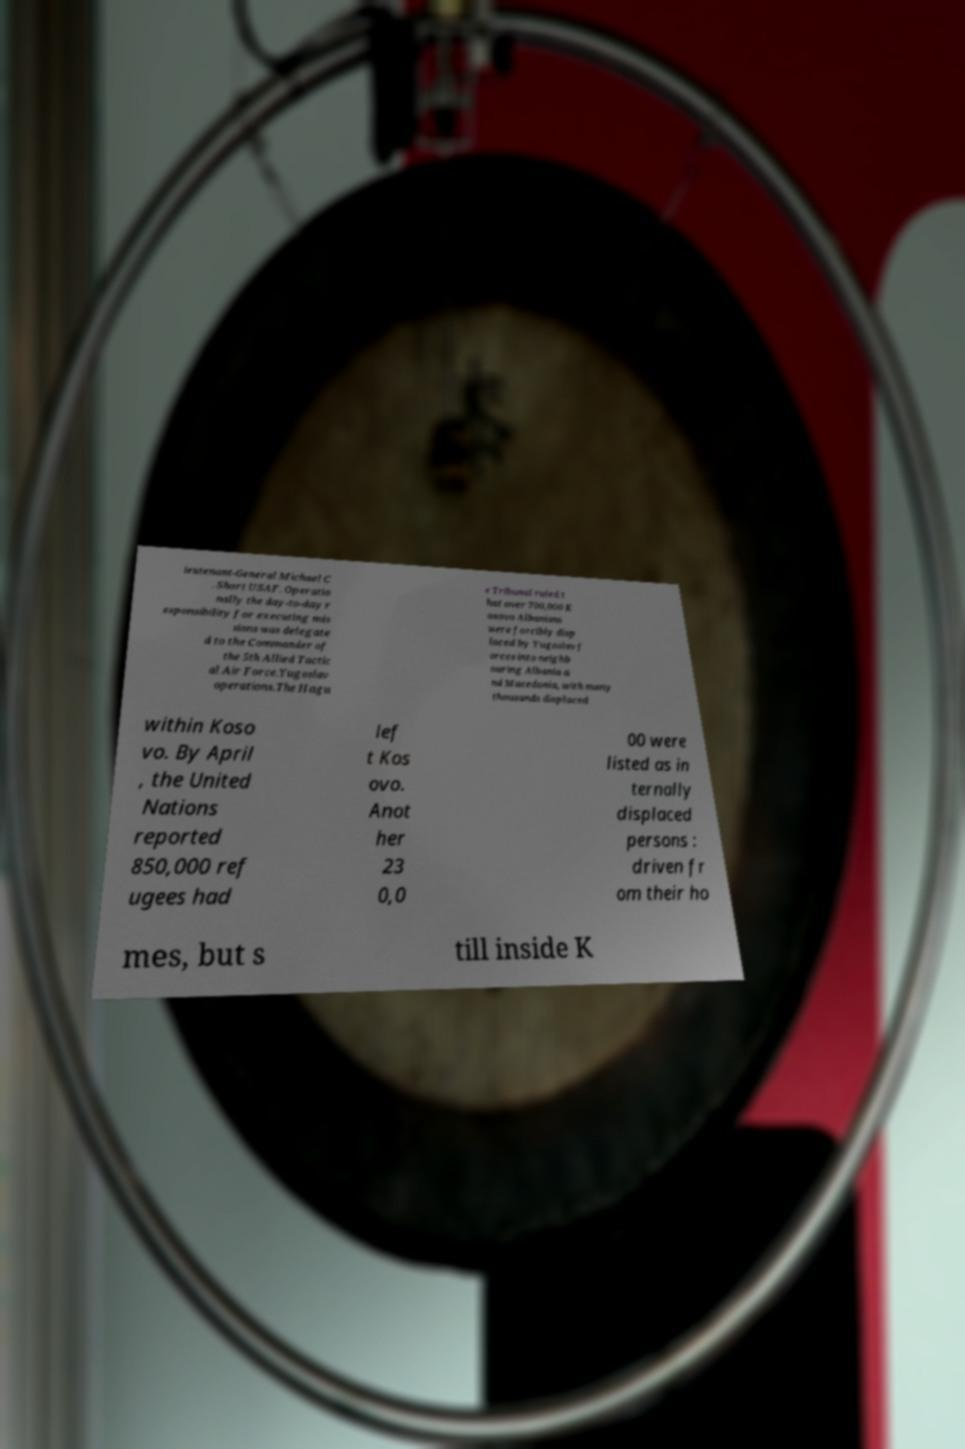Can you accurately transcribe the text from the provided image for me? ieutenant-General Michael C . Short USAF. Operatio nally the day-to-day r esponsibility for executing mis sions was delegate d to the Commander of the 5th Allied Tactic al Air Force.Yugoslav operations.The Hagu e Tribunal ruled t hat over 700,000 K osovo Albanians were forcibly disp laced by Yugoslav f orces into neighb ouring Albania a nd Macedonia, with many thousands displaced within Koso vo. By April , the United Nations reported 850,000 ref ugees had lef t Kos ovo. Anot her 23 0,0 00 were listed as in ternally displaced persons : driven fr om their ho mes, but s till inside K 